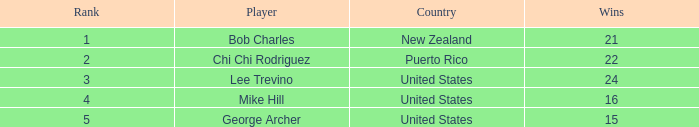Would you mind parsing the complete table? {'header': ['Rank', 'Player', 'Country', 'Wins'], 'rows': [['1', 'Bob Charles', 'New Zealand', '21'], ['2', 'Chi Chi Rodriguez', 'Puerto Rico', '22'], ['3', 'Lee Trevino', 'United States', '24'], ['4', 'Mike Hill', 'United States', '16'], ['5', 'George Archer', 'United States', '15']]} In total, how much did the United States player George Archer earn with Wins lower than 24 and a rank that was higher than 5? 0.0. 